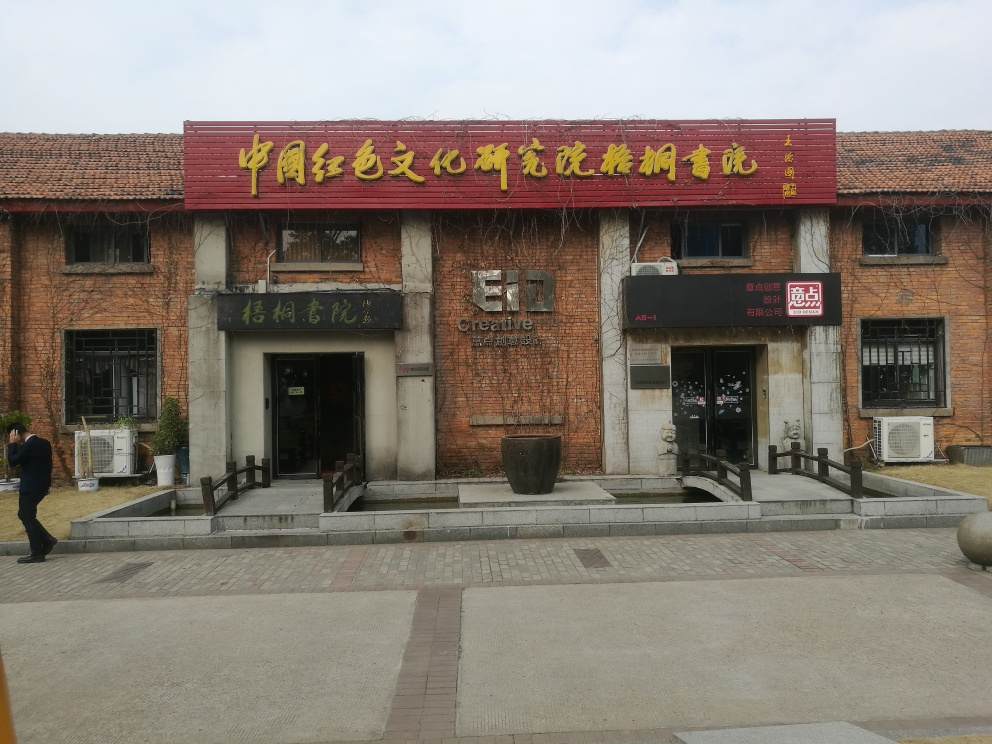Does the image provide any cultural context or historical significance? Yes, the architecture, along with the Chinese signage, locates the building within a Chinese-speaking context, possibly highlighting a space dedicated to the preservation, display, or creation of cultural artifacts or experiences. The adaptive reuse of the building may indicate an appreciation for historical preservation within a contemporary setting. 